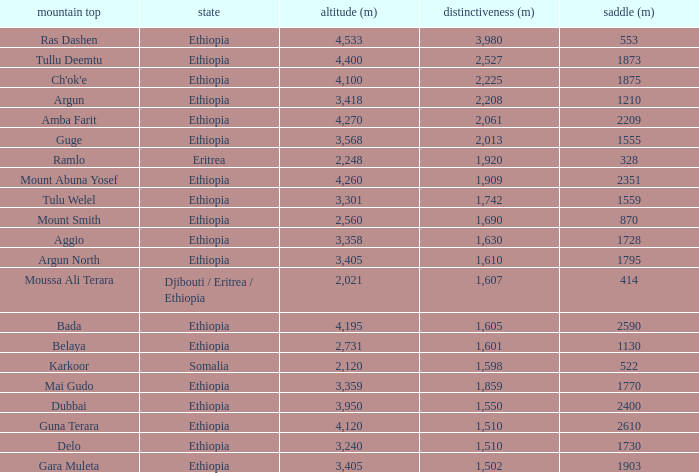What is the sum of the prominence in m of moussa ali terara peak? 1607.0. 